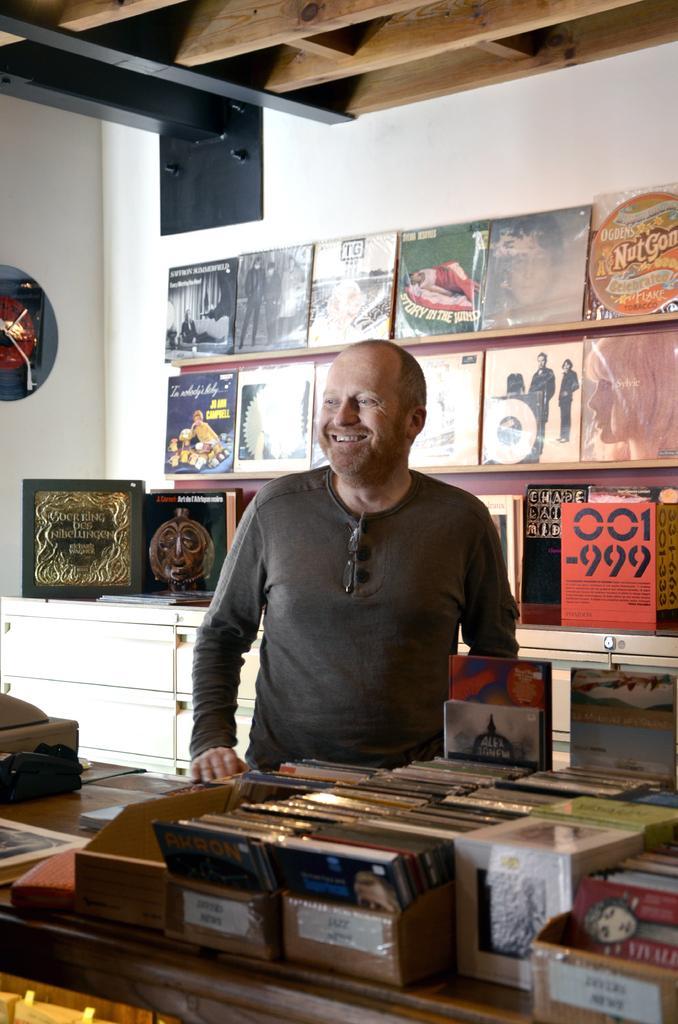Could you give a brief overview of what you see in this image? In this image the man is standing and laughing in front of him there are the cartoon and there are the things kept in this boxes in the background there are some posters kept on the shelves and there is a wall. On the left side there is a frame hanged on the wall. 